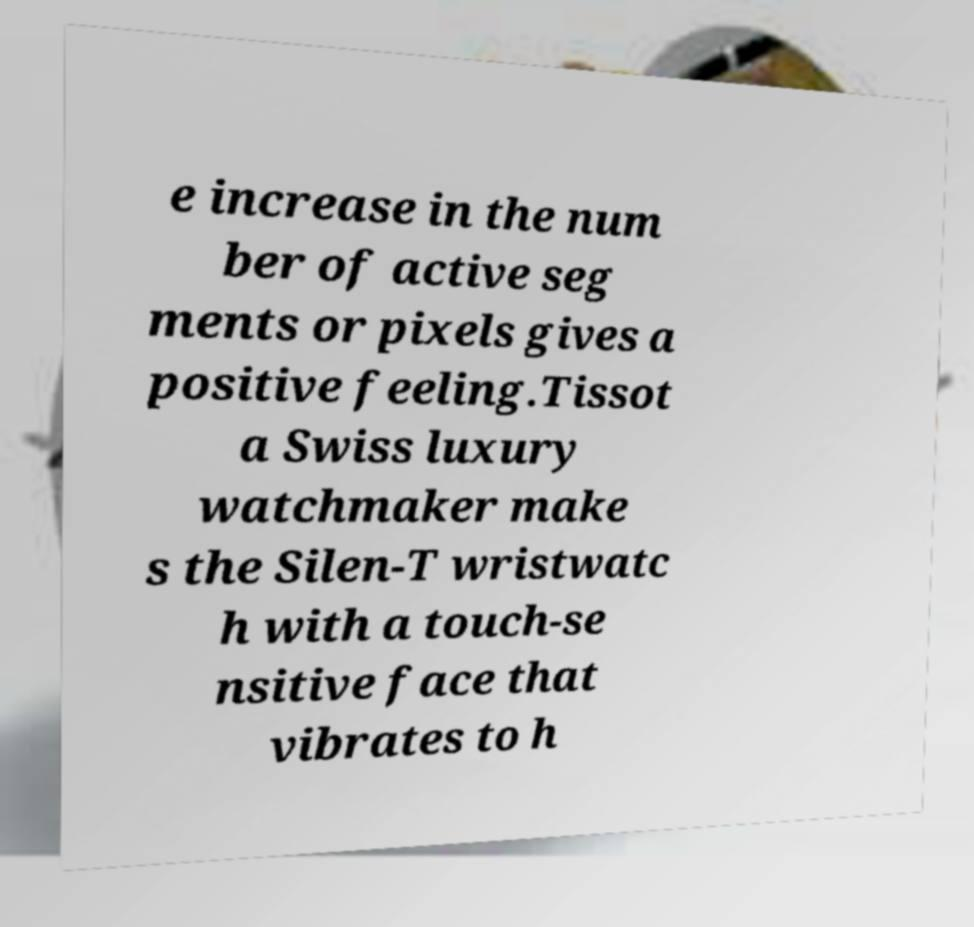I need the written content from this picture converted into text. Can you do that? e increase in the num ber of active seg ments or pixels gives a positive feeling.Tissot a Swiss luxury watchmaker make s the Silen-T wristwatc h with a touch-se nsitive face that vibrates to h 